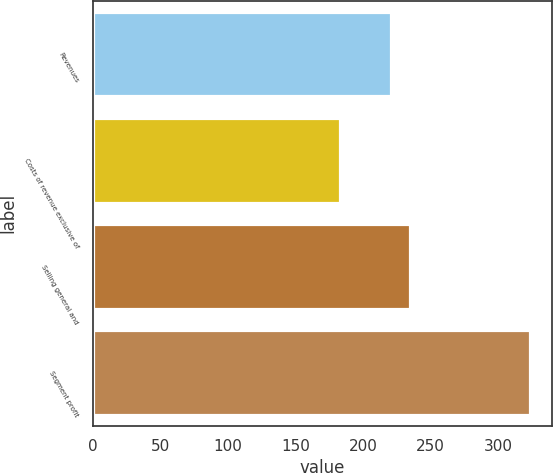Convert chart. <chart><loc_0><loc_0><loc_500><loc_500><bar_chart><fcel>Revenues<fcel>Costs of revenue exclusive of<fcel>Selling general and<fcel>Segment profit<nl><fcel>220.7<fcel>183<fcel>234.78<fcel>323.8<nl></chart> 